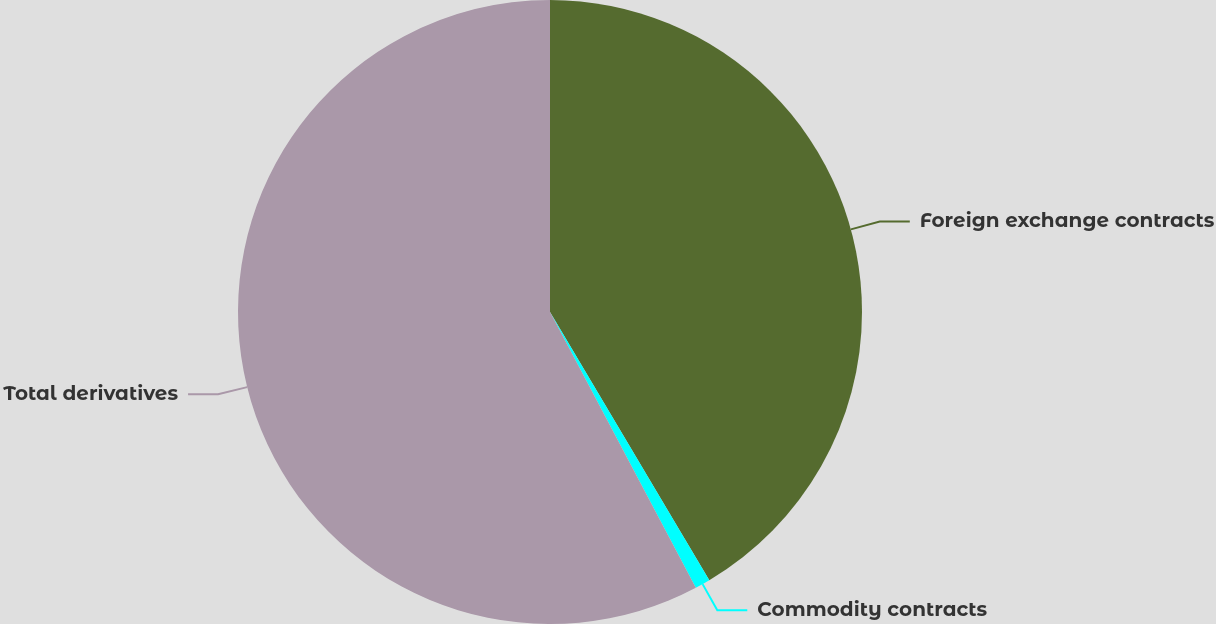Convert chart. <chart><loc_0><loc_0><loc_500><loc_500><pie_chart><fcel>Foreign exchange contracts<fcel>Commodity contracts<fcel>Total derivatives<nl><fcel>41.47%<fcel>0.79%<fcel>57.74%<nl></chart> 